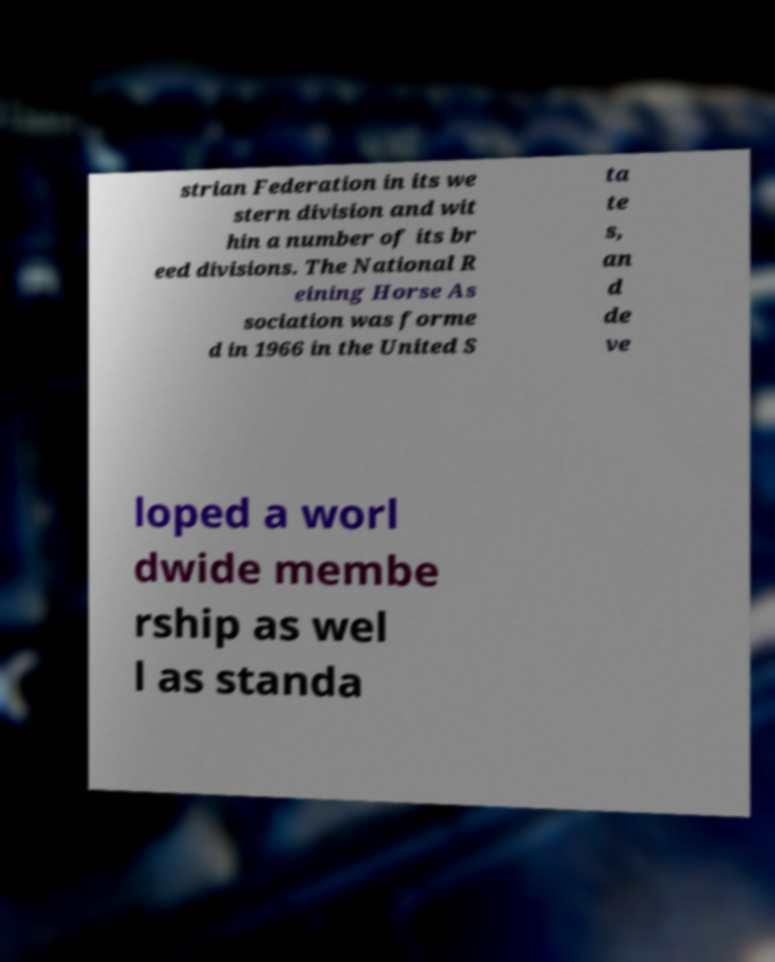I need the written content from this picture converted into text. Can you do that? strian Federation in its we stern division and wit hin a number of its br eed divisions. The National R eining Horse As sociation was forme d in 1966 in the United S ta te s, an d de ve loped a worl dwide membe rship as wel l as standa 